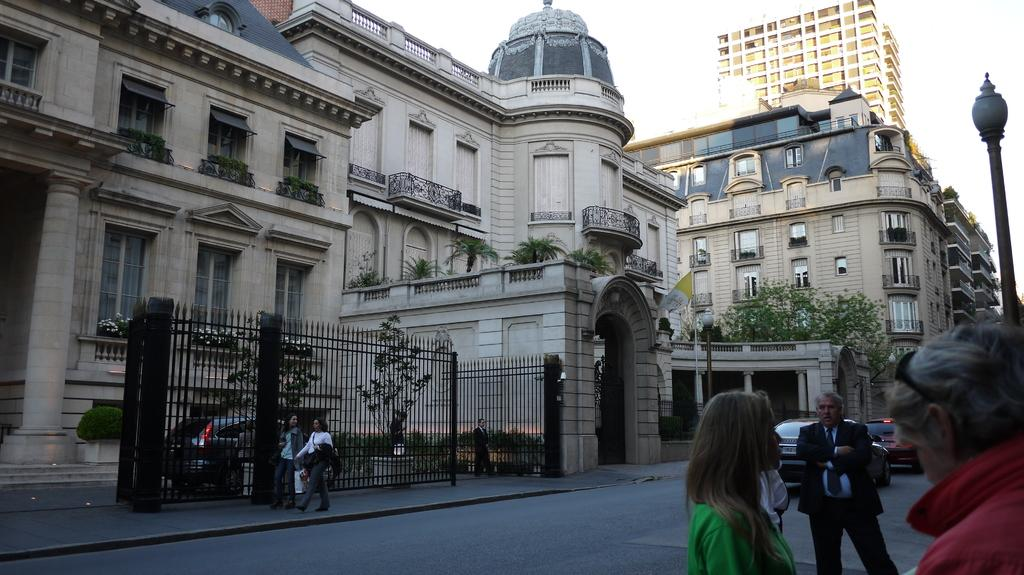How many people are in the image? There is a group of people in the image, but the exact number cannot be determined from the provided facts. What else can be seen on the road in the image? There are vehicles on the road in the image. What is visible in the background of the image? There are buildings and the sky visible in the background of the image. Can you tell me how many wheels are on the river in the image? There is no river present in the image, and therefore no wheels can be found on it. 